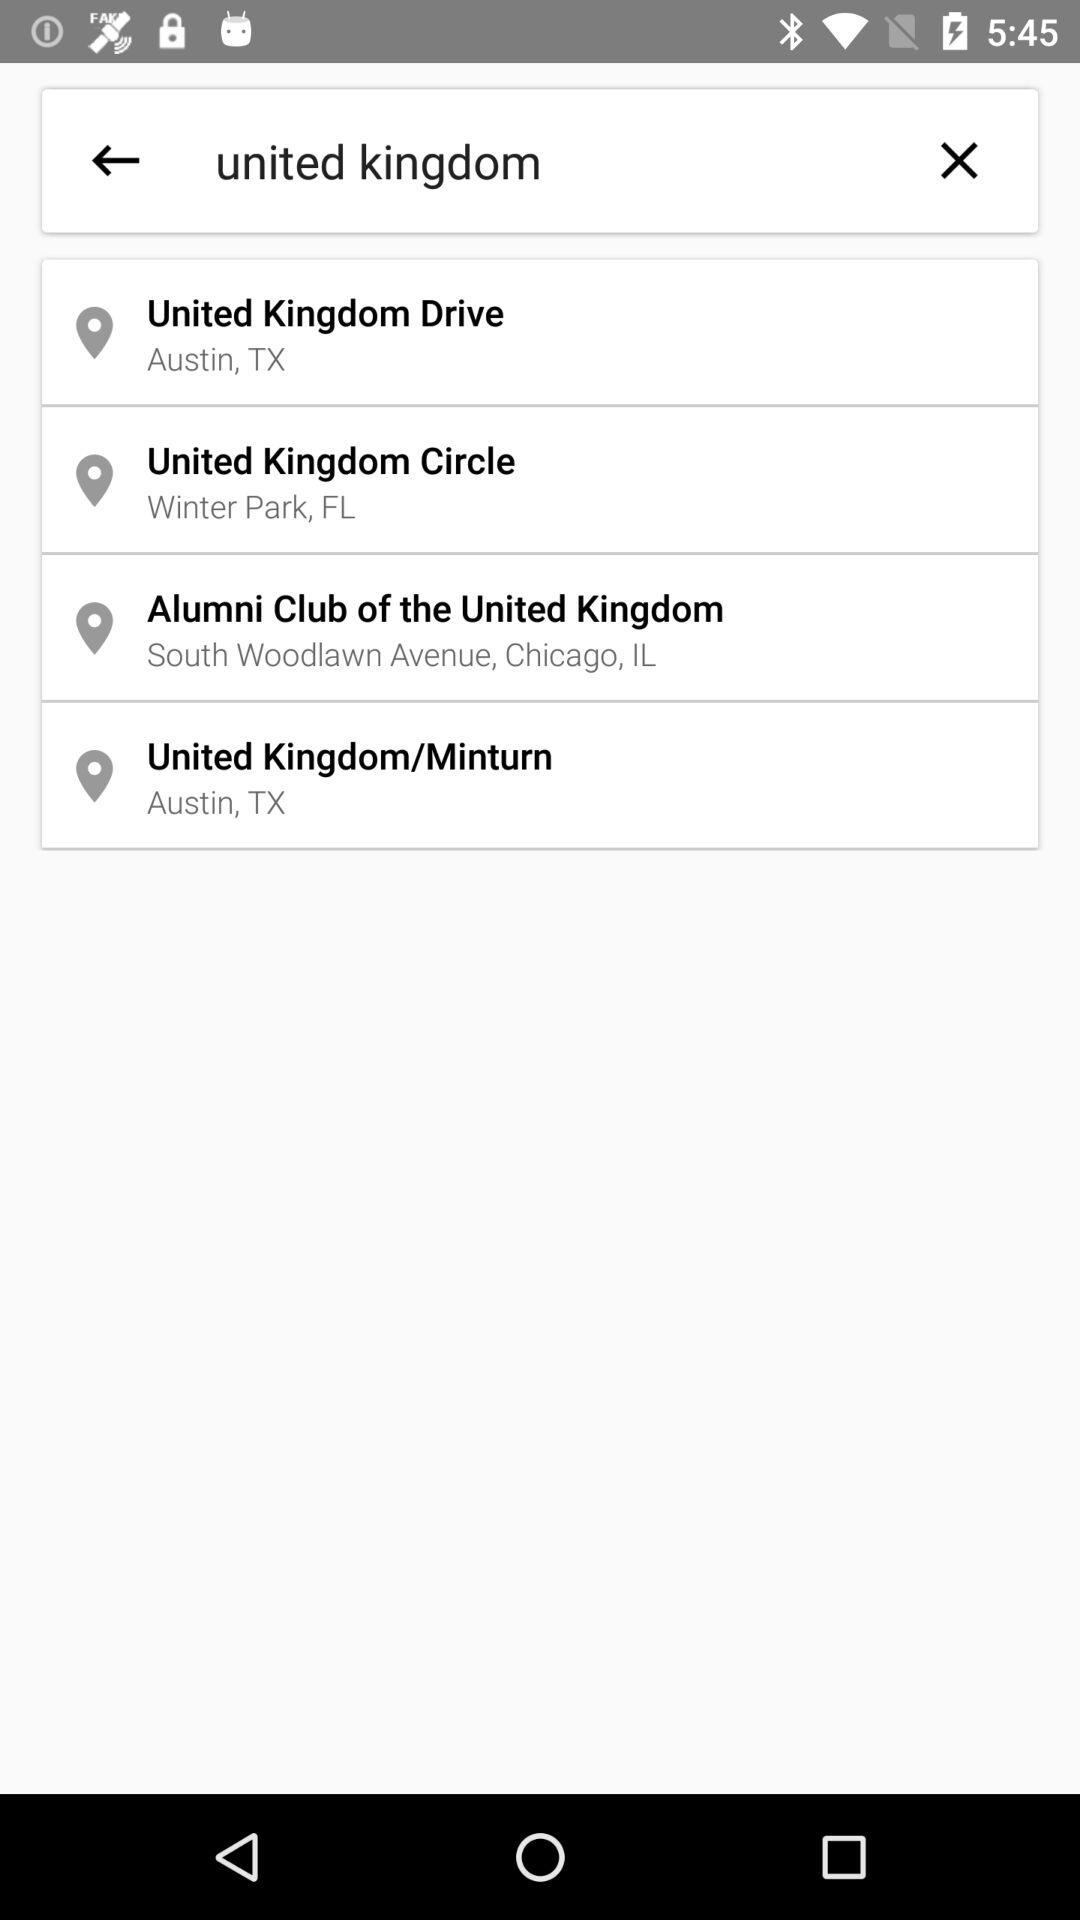What is the location of the United Kingdom Circle? The location is Winter Park, FL. 